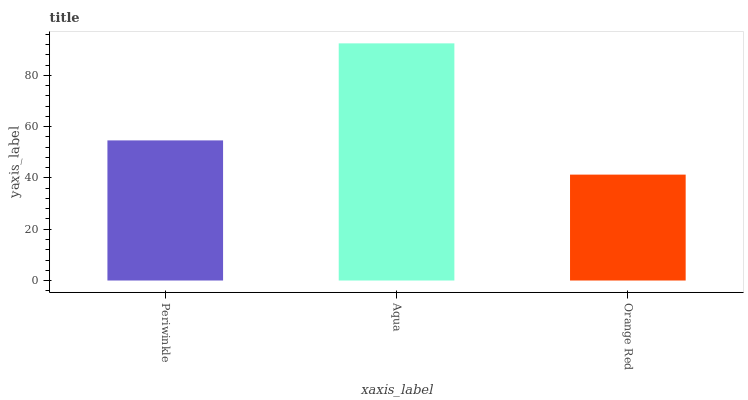Is Orange Red the minimum?
Answer yes or no. Yes. Is Aqua the maximum?
Answer yes or no. Yes. Is Aqua the minimum?
Answer yes or no. No. Is Orange Red the maximum?
Answer yes or no. No. Is Aqua greater than Orange Red?
Answer yes or no. Yes. Is Orange Red less than Aqua?
Answer yes or no. Yes. Is Orange Red greater than Aqua?
Answer yes or no. No. Is Aqua less than Orange Red?
Answer yes or no. No. Is Periwinkle the high median?
Answer yes or no. Yes. Is Periwinkle the low median?
Answer yes or no. Yes. Is Orange Red the high median?
Answer yes or no. No. Is Aqua the low median?
Answer yes or no. No. 